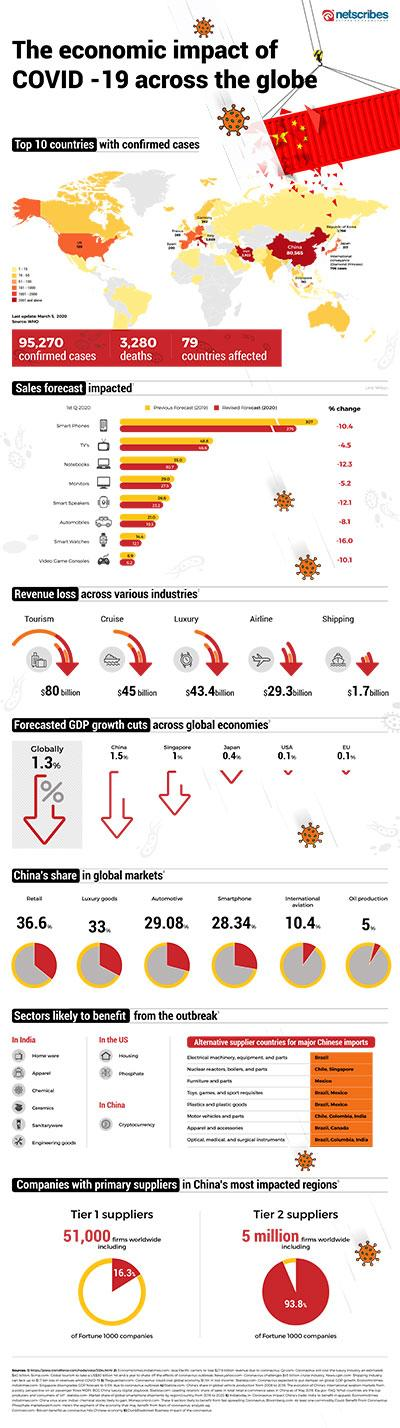Highlight a few significant elements in this photo. The global airline industry has incurred a revenue loss of approximately $29.3 billion due to the impact of COVID-19. The global tourism industry has suffered a revenue loss of approximately $80 billion due to the impact of COVID-19. 